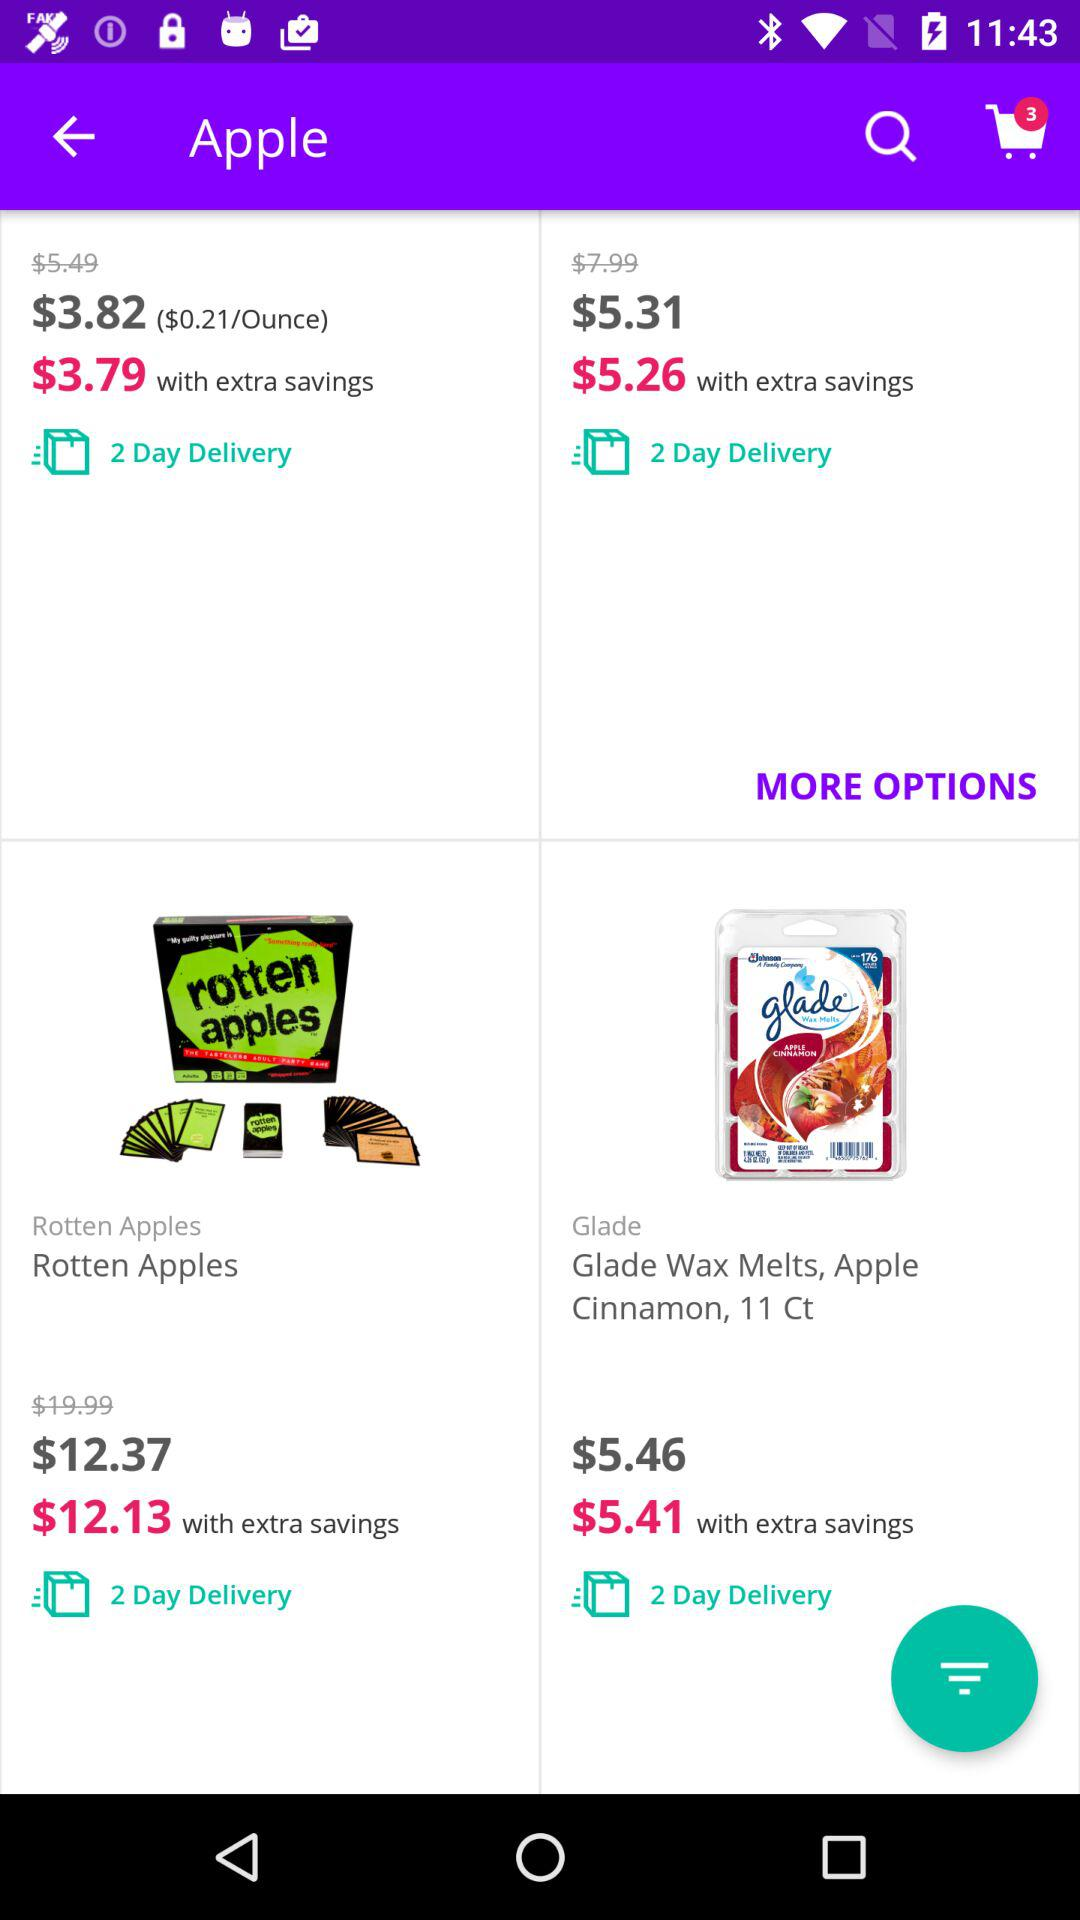How much is the sales tax on the rotten apples?
When the provided information is insufficient, respond with <no answer>. <no answer> 